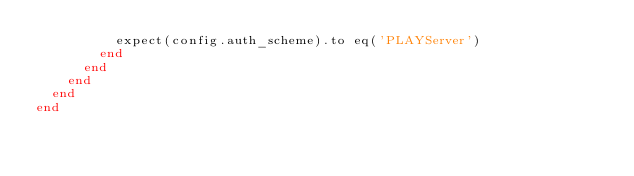<code> <loc_0><loc_0><loc_500><loc_500><_Ruby_>          expect(config.auth_scheme).to eq('PLAYServer')
        end
      end
    end
  end
end
</code> 